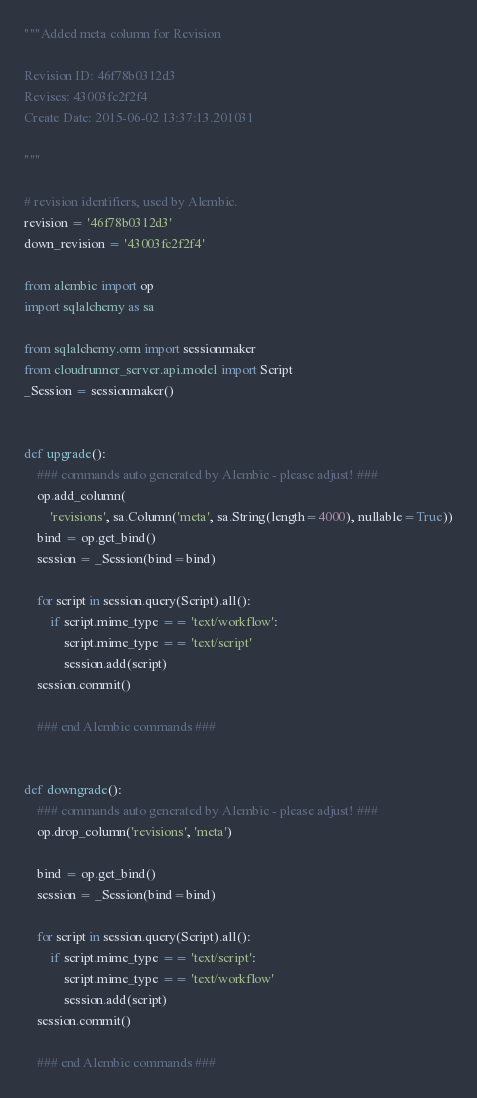<code> <loc_0><loc_0><loc_500><loc_500><_Python_>"""Added meta column for Revision

Revision ID: 46f78b0312d3
Revises: 43003fc2f2f4
Create Date: 2015-06-02 13:37:13.201031

"""

# revision identifiers, used by Alembic.
revision = '46f78b0312d3'
down_revision = '43003fc2f2f4'

from alembic import op
import sqlalchemy as sa

from sqlalchemy.orm import sessionmaker
from cloudrunner_server.api.model import Script
_Session = sessionmaker()


def upgrade():
    ### commands auto generated by Alembic - please adjust! ###
    op.add_column(
        'revisions', sa.Column('meta', sa.String(length=4000), nullable=True))
    bind = op.get_bind()
    session = _Session(bind=bind)

    for script in session.query(Script).all():
        if script.mime_type == 'text/workflow':
            script.mime_type == 'text/script'
            session.add(script)
    session.commit()

    ### end Alembic commands ###


def downgrade():
    ### commands auto generated by Alembic - please adjust! ###
    op.drop_column('revisions', 'meta')

    bind = op.get_bind()
    session = _Session(bind=bind)

    for script in session.query(Script).all():
        if script.mime_type == 'text/script':
            script.mime_type == 'text/workflow'
            session.add(script)
    session.commit()

    ### end Alembic commands ###
</code> 